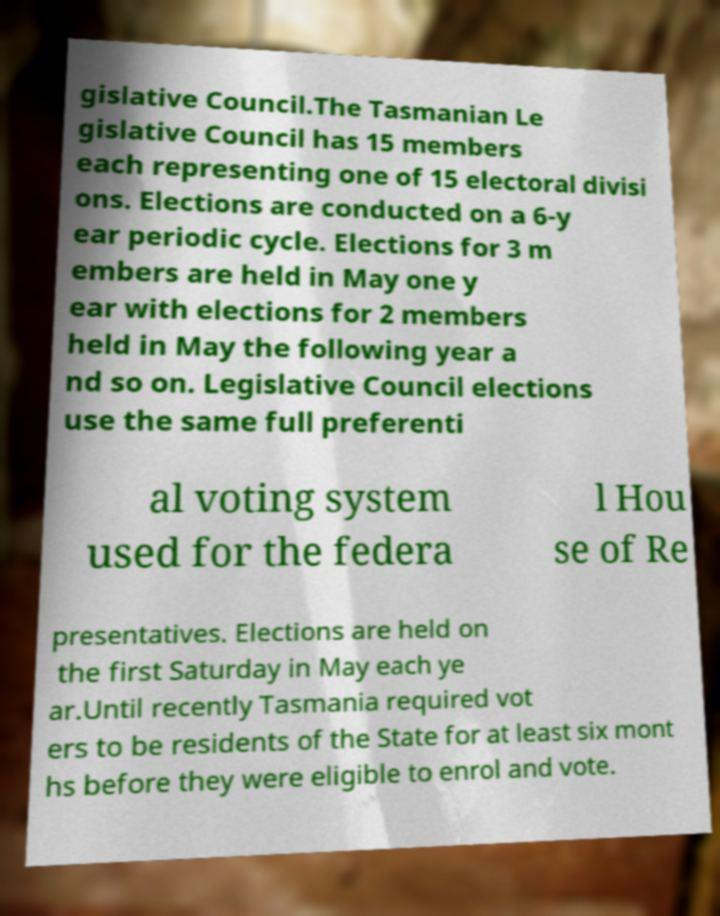Could you extract and type out the text from this image? gislative Council.The Tasmanian Le gislative Council has 15 members each representing one of 15 electoral divisi ons. Elections are conducted on a 6-y ear periodic cycle. Elections for 3 m embers are held in May one y ear with elections for 2 members held in May the following year a nd so on. Legislative Council elections use the same full preferenti al voting system used for the federa l Hou se of Re presentatives. Elections are held on the first Saturday in May each ye ar.Until recently Tasmania required vot ers to be residents of the State for at least six mont hs before they were eligible to enrol and vote. 